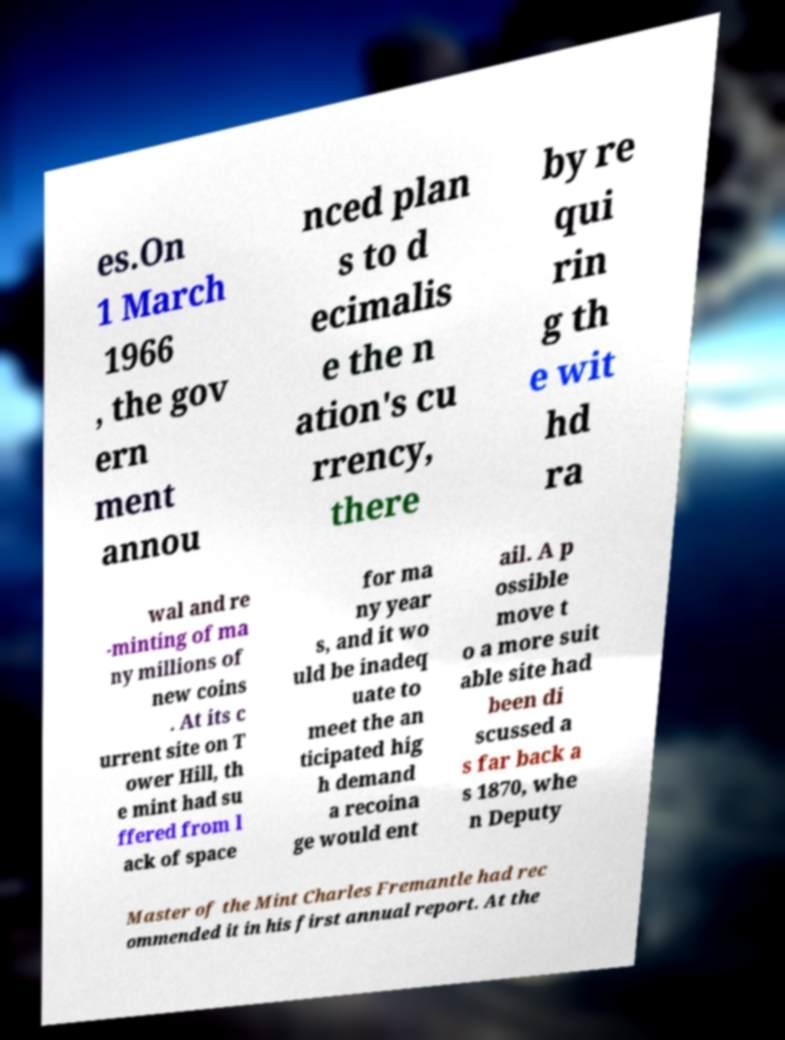There's text embedded in this image that I need extracted. Can you transcribe it verbatim? es.On 1 March 1966 , the gov ern ment annou nced plan s to d ecimalis e the n ation's cu rrency, there by re qui rin g th e wit hd ra wal and re -minting of ma ny millions of new coins . At its c urrent site on T ower Hill, th e mint had su ffered from l ack of space for ma ny year s, and it wo uld be inadeq uate to meet the an ticipated hig h demand a recoina ge would ent ail. A p ossible move t o a more suit able site had been di scussed a s far back a s 1870, whe n Deputy Master of the Mint Charles Fremantle had rec ommended it in his first annual report. At the 